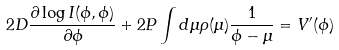<formula> <loc_0><loc_0><loc_500><loc_500>2 D \frac { \partial \log I ( \phi , \phi ) } { \partial \phi } + 2 P \int d \mu \rho ( \mu ) \frac { 1 } { \phi - \mu } = V ^ { \prime } ( \phi )</formula> 